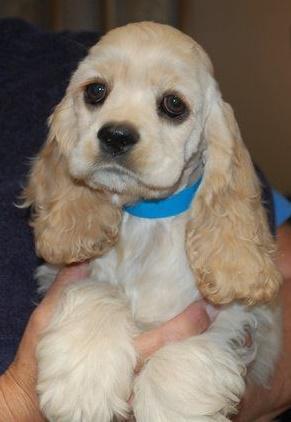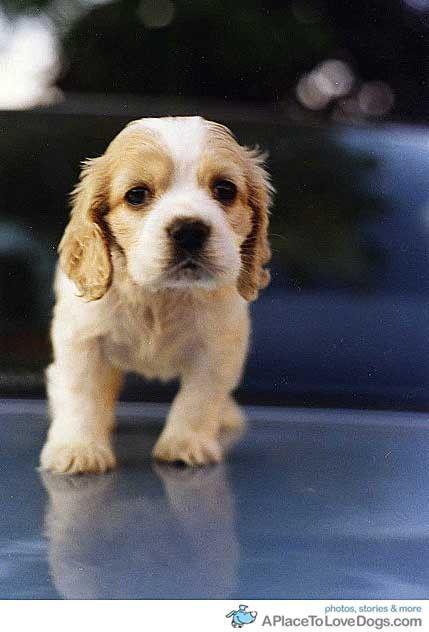The first image is the image on the left, the second image is the image on the right. Considering the images on both sides, is "The left image shows no less than three spaniel puppies, and the right image shows just one spaniel sitting" valid? Answer yes or no. No. The first image is the image on the left, the second image is the image on the right. Assess this claim about the two images: "The left image contains at least three dogs.". Correct or not? Answer yes or no. No. 